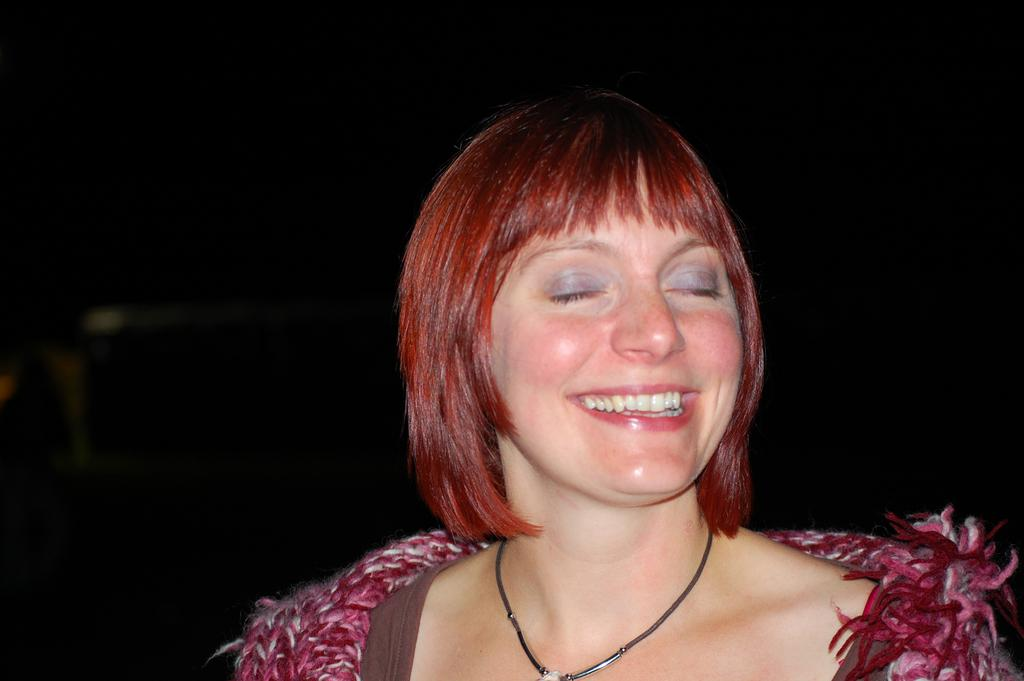Who is the main subject in the image? There is a woman in the image. What can be seen in the background of the image? The background of the image is black. What type of soda is the woman holding in the image? There is no soda present in the image; the woman is the only subject visible. 